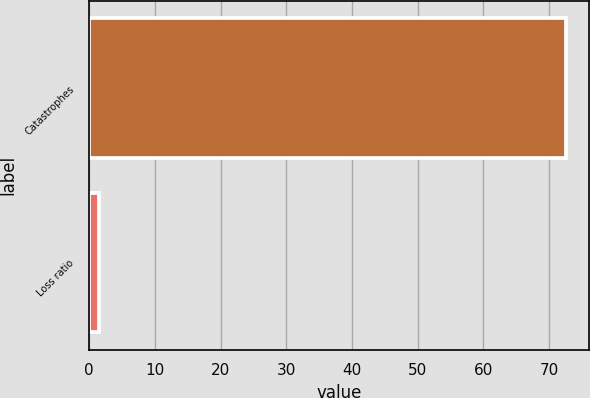<chart> <loc_0><loc_0><loc_500><loc_500><bar_chart><fcel>Catastrophes<fcel>Loss ratio<nl><fcel>72.5<fcel>1.5<nl></chart> 